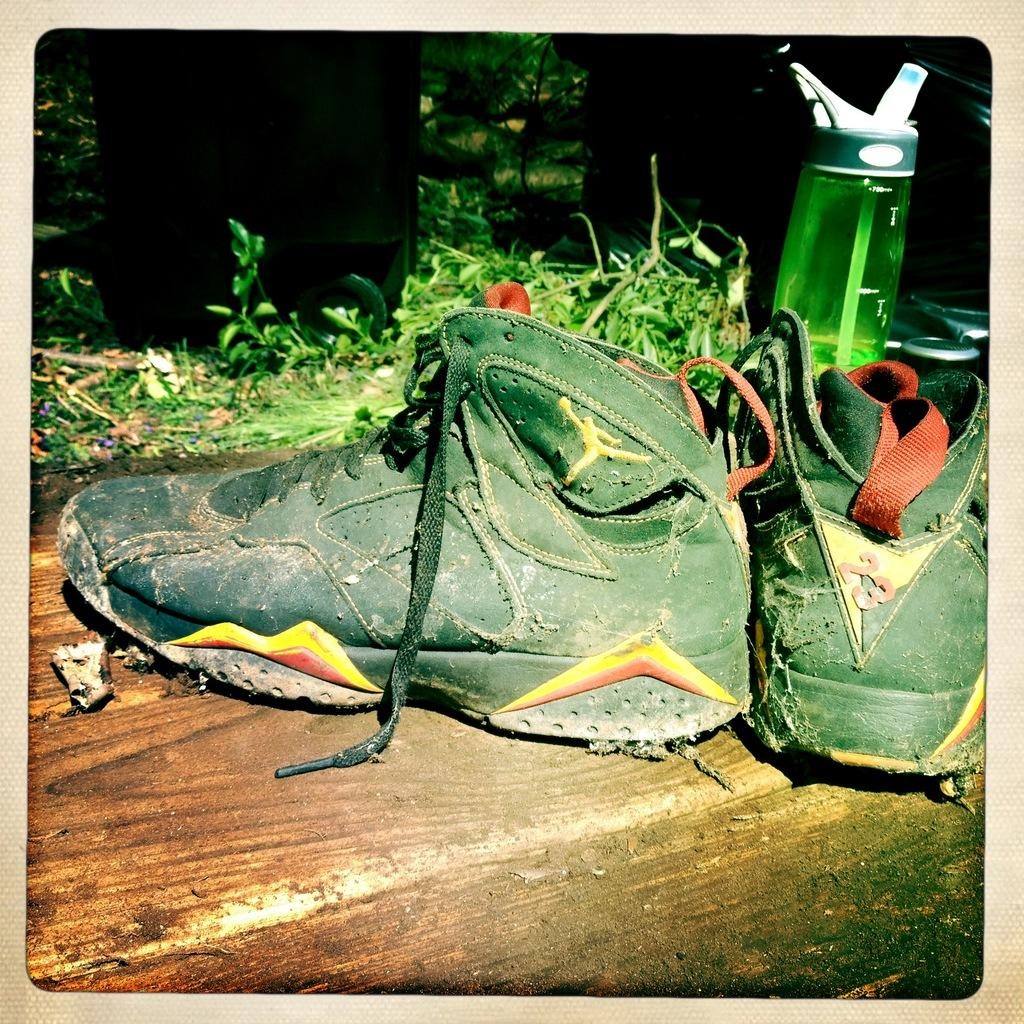What type of footwear is visible in the image? There are shoes in the image. What color are the shoes? The shoes are green. What other green object is present in the image? There is a bottle in the image, and it is green. What can be seen in the background of the image? There are green color plants in the background of the image. What type of stew is being served in the image? There is no stew present in the image; it features shoes, a green bottle, and green plants in the background. Can you hear the voice of the person who took the picture? There is no information about the person who took the picture or any audible elements in the image. 